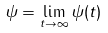<formula> <loc_0><loc_0><loc_500><loc_500>\psi & = \lim _ { t \to \infty } \psi ( t )</formula> 